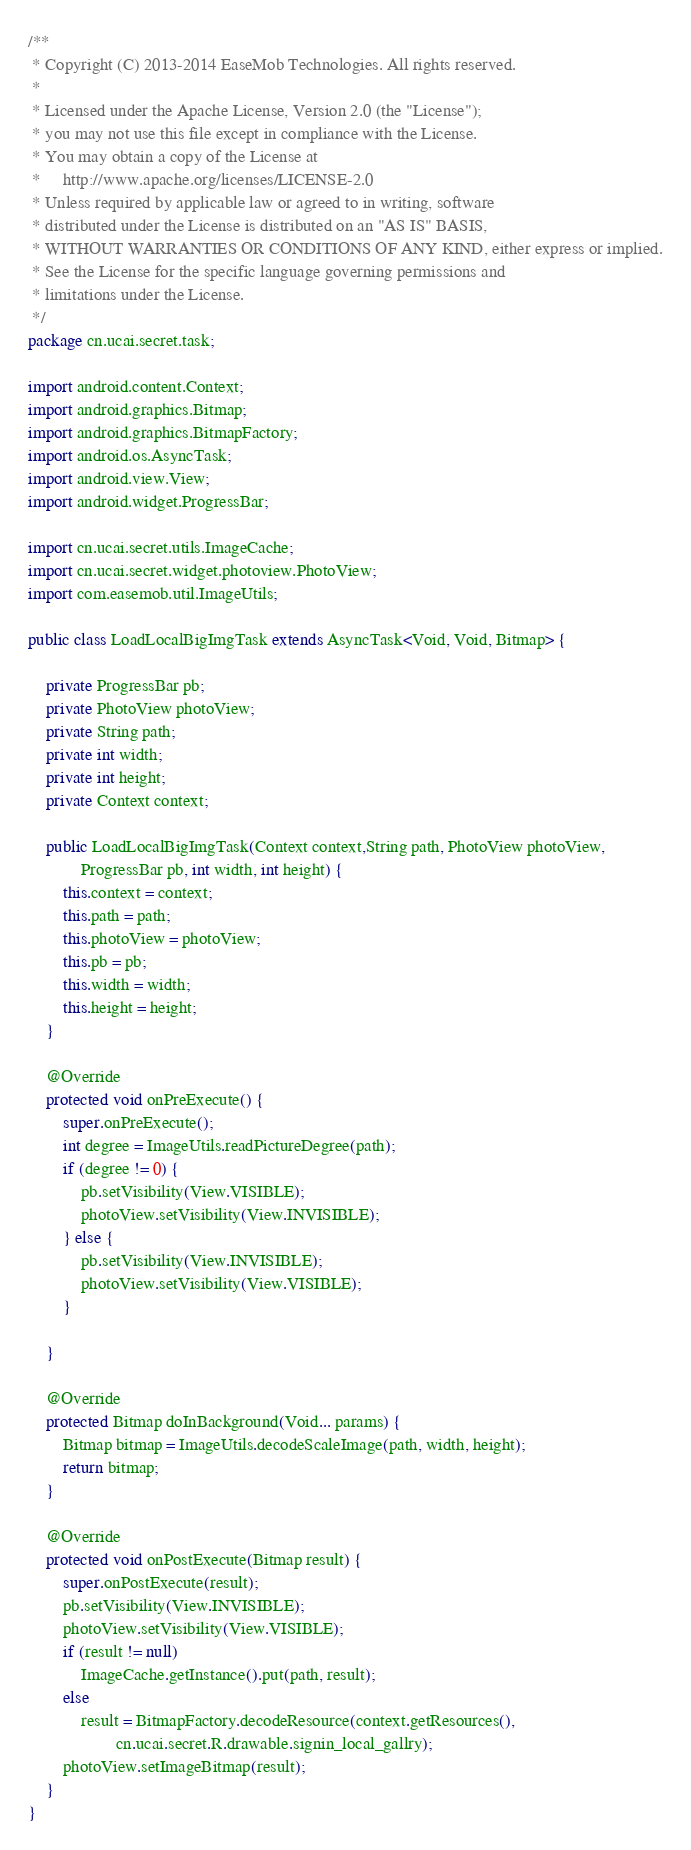Convert code to text. <code><loc_0><loc_0><loc_500><loc_500><_Java_>/**
 * Copyright (C) 2013-2014 EaseMob Technologies. All rights reserved.
 *
 * Licensed under the Apache License, Version 2.0 (the "License");
 * you may not use this file except in compliance with the License.
 * You may obtain a copy of the License at
 *     http://www.apache.org/licenses/LICENSE-2.0
 * Unless required by applicable law or agreed to in writing, software
 * distributed under the License is distributed on an "AS IS" BASIS,
 * WITHOUT WARRANTIES OR CONDITIONS OF ANY KIND, either express or implied.
 * See the License for the specific language governing permissions and
 * limitations under the License.
 */
package cn.ucai.secret.task;

import android.content.Context;
import android.graphics.Bitmap;
import android.graphics.BitmapFactory;
import android.os.AsyncTask;
import android.view.View;
import android.widget.ProgressBar;

import cn.ucai.secret.utils.ImageCache;
import cn.ucai.secret.widget.photoview.PhotoView;
import com.easemob.util.ImageUtils;

public class LoadLocalBigImgTask extends AsyncTask<Void, Void, Bitmap> {

	private ProgressBar pb;
	private PhotoView photoView;
	private String path;
	private int width;
	private int height;
	private Context context;

	public LoadLocalBigImgTask(Context context,String path, PhotoView photoView,
			ProgressBar pb, int width, int height) {
		this.context = context;
		this.path = path;
		this.photoView = photoView;
		this.pb = pb;
		this.width = width;
		this.height = height;
	}

	@Override
	protected void onPreExecute() {
		super.onPreExecute();
		int degree = ImageUtils.readPictureDegree(path);
		if (degree != 0) {
			pb.setVisibility(View.VISIBLE);
			photoView.setVisibility(View.INVISIBLE);
		} else {
			pb.setVisibility(View.INVISIBLE);
			photoView.setVisibility(View.VISIBLE);
		}

	}

	@Override
	protected Bitmap doInBackground(Void... params) {
		Bitmap bitmap = ImageUtils.decodeScaleImage(path, width, height);
		return bitmap;
	}

	@Override
	protected void onPostExecute(Bitmap result) {
		super.onPostExecute(result);
		pb.setVisibility(View.INVISIBLE);
		photoView.setVisibility(View.VISIBLE);
		if (result != null)
			ImageCache.getInstance().put(path, result);
		else
			result = BitmapFactory.decodeResource(context.getResources(),
					cn.ucai.secret.R.drawable.signin_local_gallry);
		photoView.setImageBitmap(result);
	}
}
</code> 